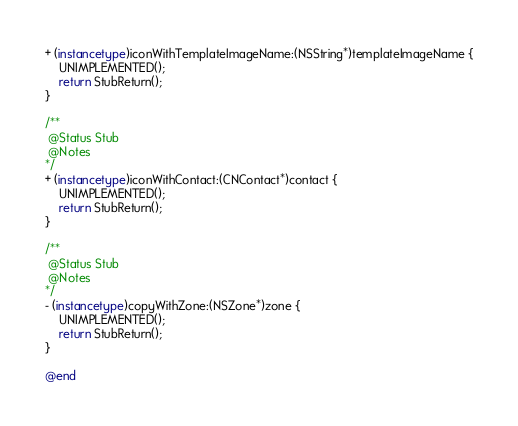<code> <loc_0><loc_0><loc_500><loc_500><_ObjectiveC_>+ (instancetype)iconWithTemplateImageName:(NSString*)templateImageName {
    UNIMPLEMENTED();
    return StubReturn();
}

/**
 @Status Stub
 @Notes
*/
+ (instancetype)iconWithContact:(CNContact*)contact {
    UNIMPLEMENTED();
    return StubReturn();
}

/**
 @Status Stub
 @Notes
*/
- (instancetype)copyWithZone:(NSZone*)zone {
    UNIMPLEMENTED();
    return StubReturn();
}

@end
</code> 